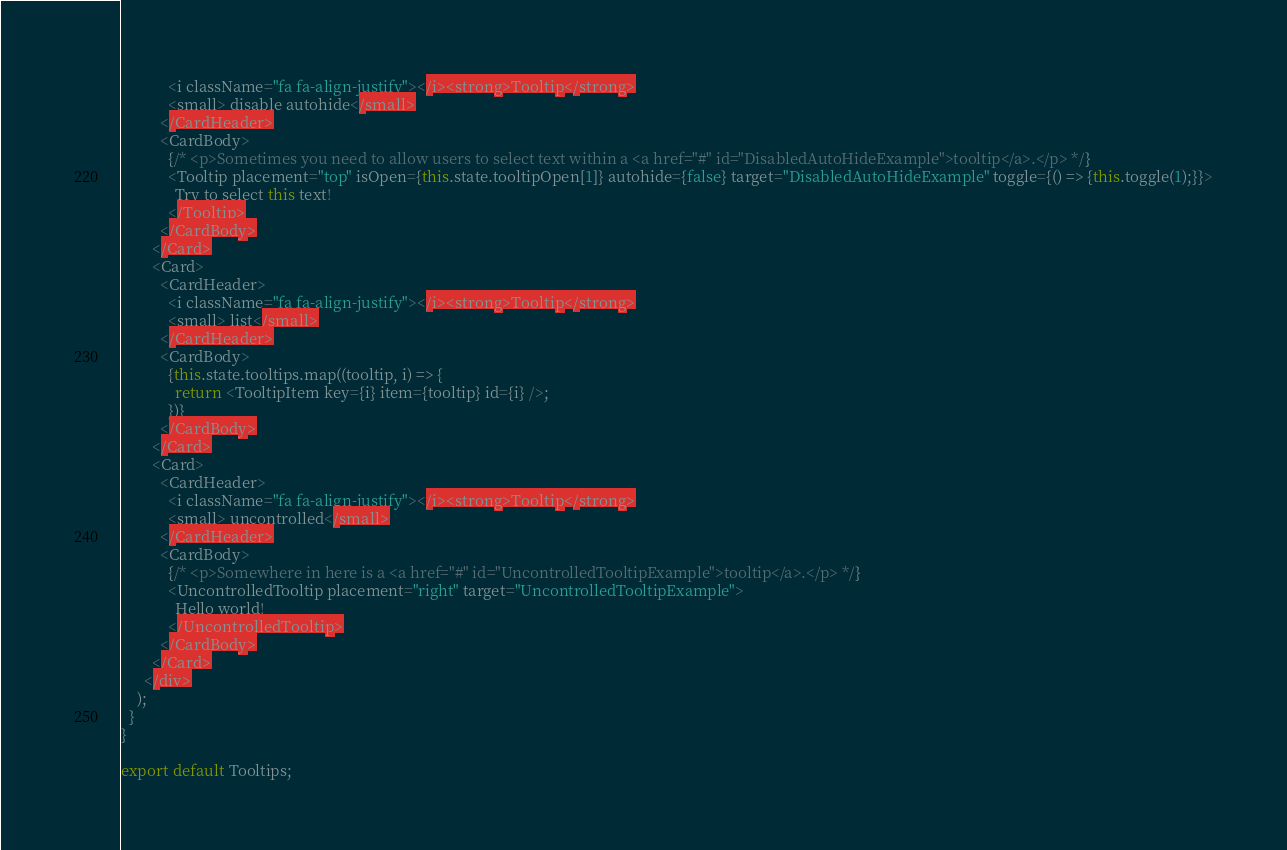<code> <loc_0><loc_0><loc_500><loc_500><_JavaScript_>            <i className="fa fa-align-justify"></i><strong>Tooltip</strong>
            <small> disable autohide</small>
          </CardHeader>
          <CardBody>
            {/* <p>Sometimes you need to allow users to select text within a <a href="#" id="DisabledAutoHideExample">tooltip</a>.</p> */}
            <Tooltip placement="top" isOpen={this.state.tooltipOpen[1]} autohide={false} target="DisabledAutoHideExample" toggle={() => {this.toggle(1);}}>
              Try to select this text!
            </Tooltip>
          </CardBody>
        </Card>
        <Card>
          <CardHeader>
            <i className="fa fa-align-justify"></i><strong>Tooltip</strong>
            <small> list</small>
          </CardHeader>
          <CardBody>
            {this.state.tooltips.map((tooltip, i) => {
              return <TooltipItem key={i} item={tooltip} id={i} />;
            })}
          </CardBody>
        </Card>
        <Card>
          <CardHeader>
            <i className="fa fa-align-justify"></i><strong>Tooltip</strong>
            <small> uncontrolled</small>
          </CardHeader>
          <CardBody>
            {/* <p>Somewhere in here is a <a href="#" id="UncontrolledTooltipExample">tooltip</a>.</p> */}
            <UncontrolledTooltip placement="right" target="UncontrolledTooltipExample">
              Hello world!
            </UncontrolledTooltip>
          </CardBody>
        </Card>
      </div>
    );
  }
}

export default Tooltips;</code> 